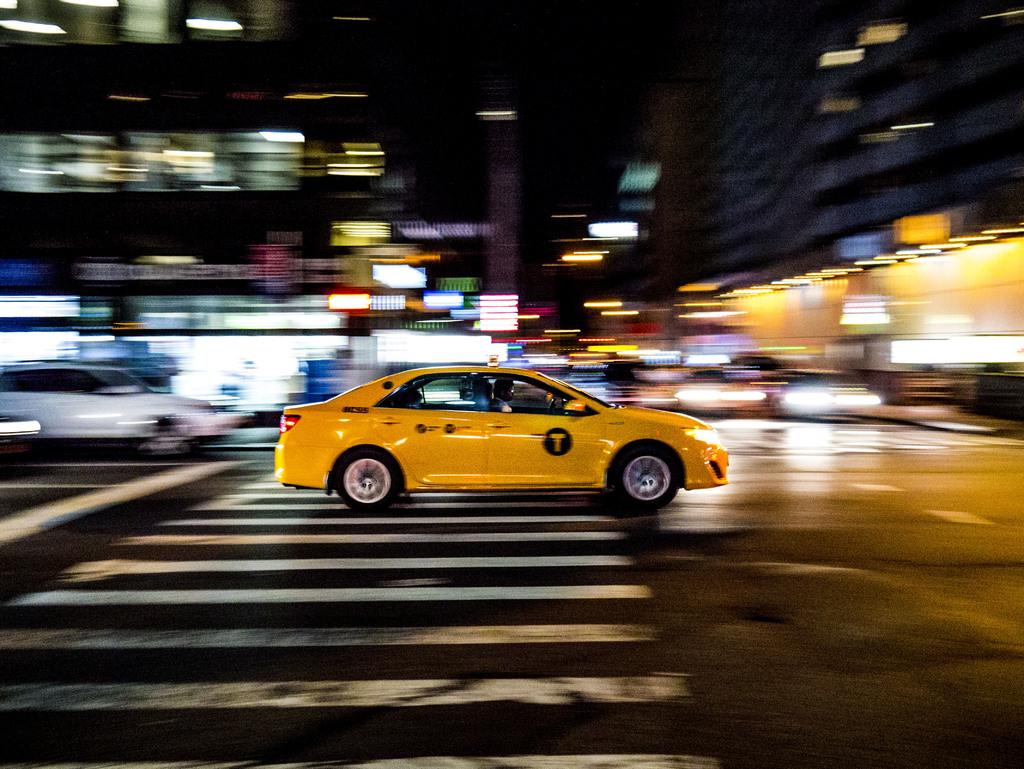What type of car is this?
Make the answer very short. Taxi. What letter is on the cars side?
Keep it short and to the point. T. 